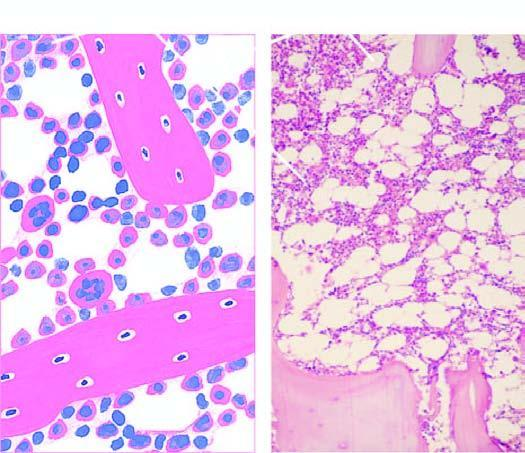does circle shown with yellow-orange line consist of haematopoietic tissue?
Answer the question using a single word or phrase. No 